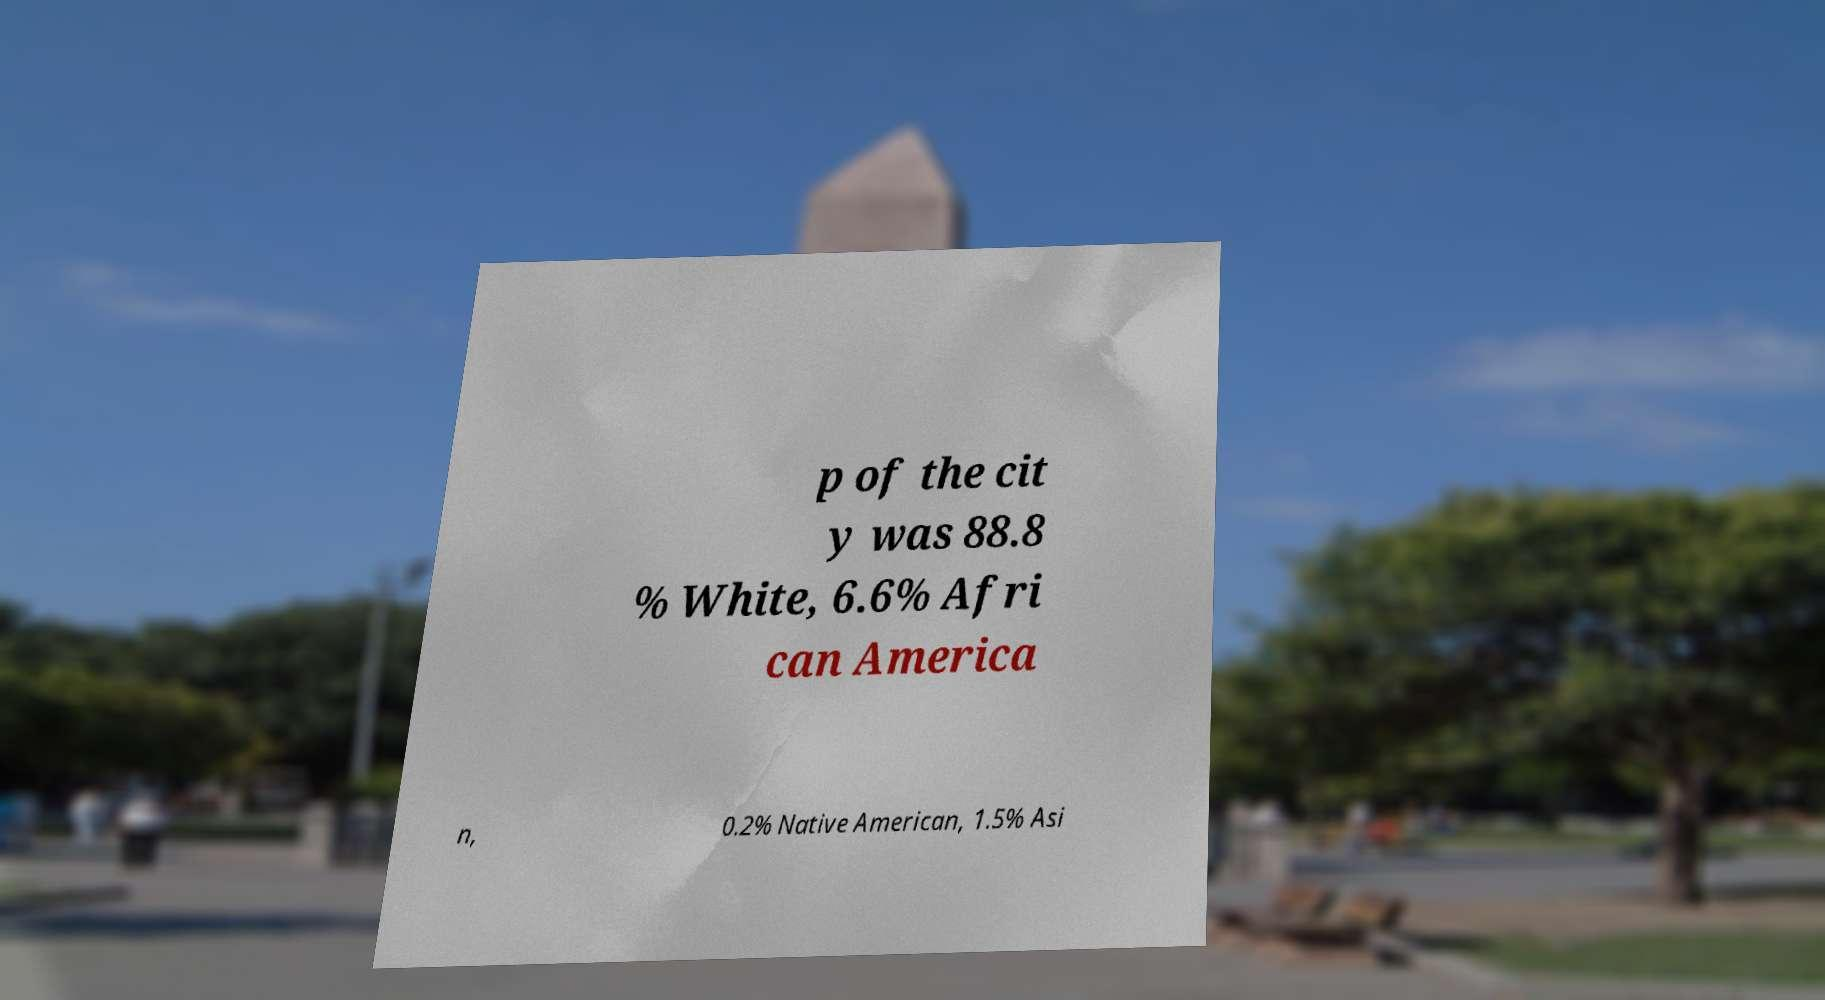Please read and relay the text visible in this image. What does it say? p of the cit y was 88.8 % White, 6.6% Afri can America n, 0.2% Native American, 1.5% Asi 